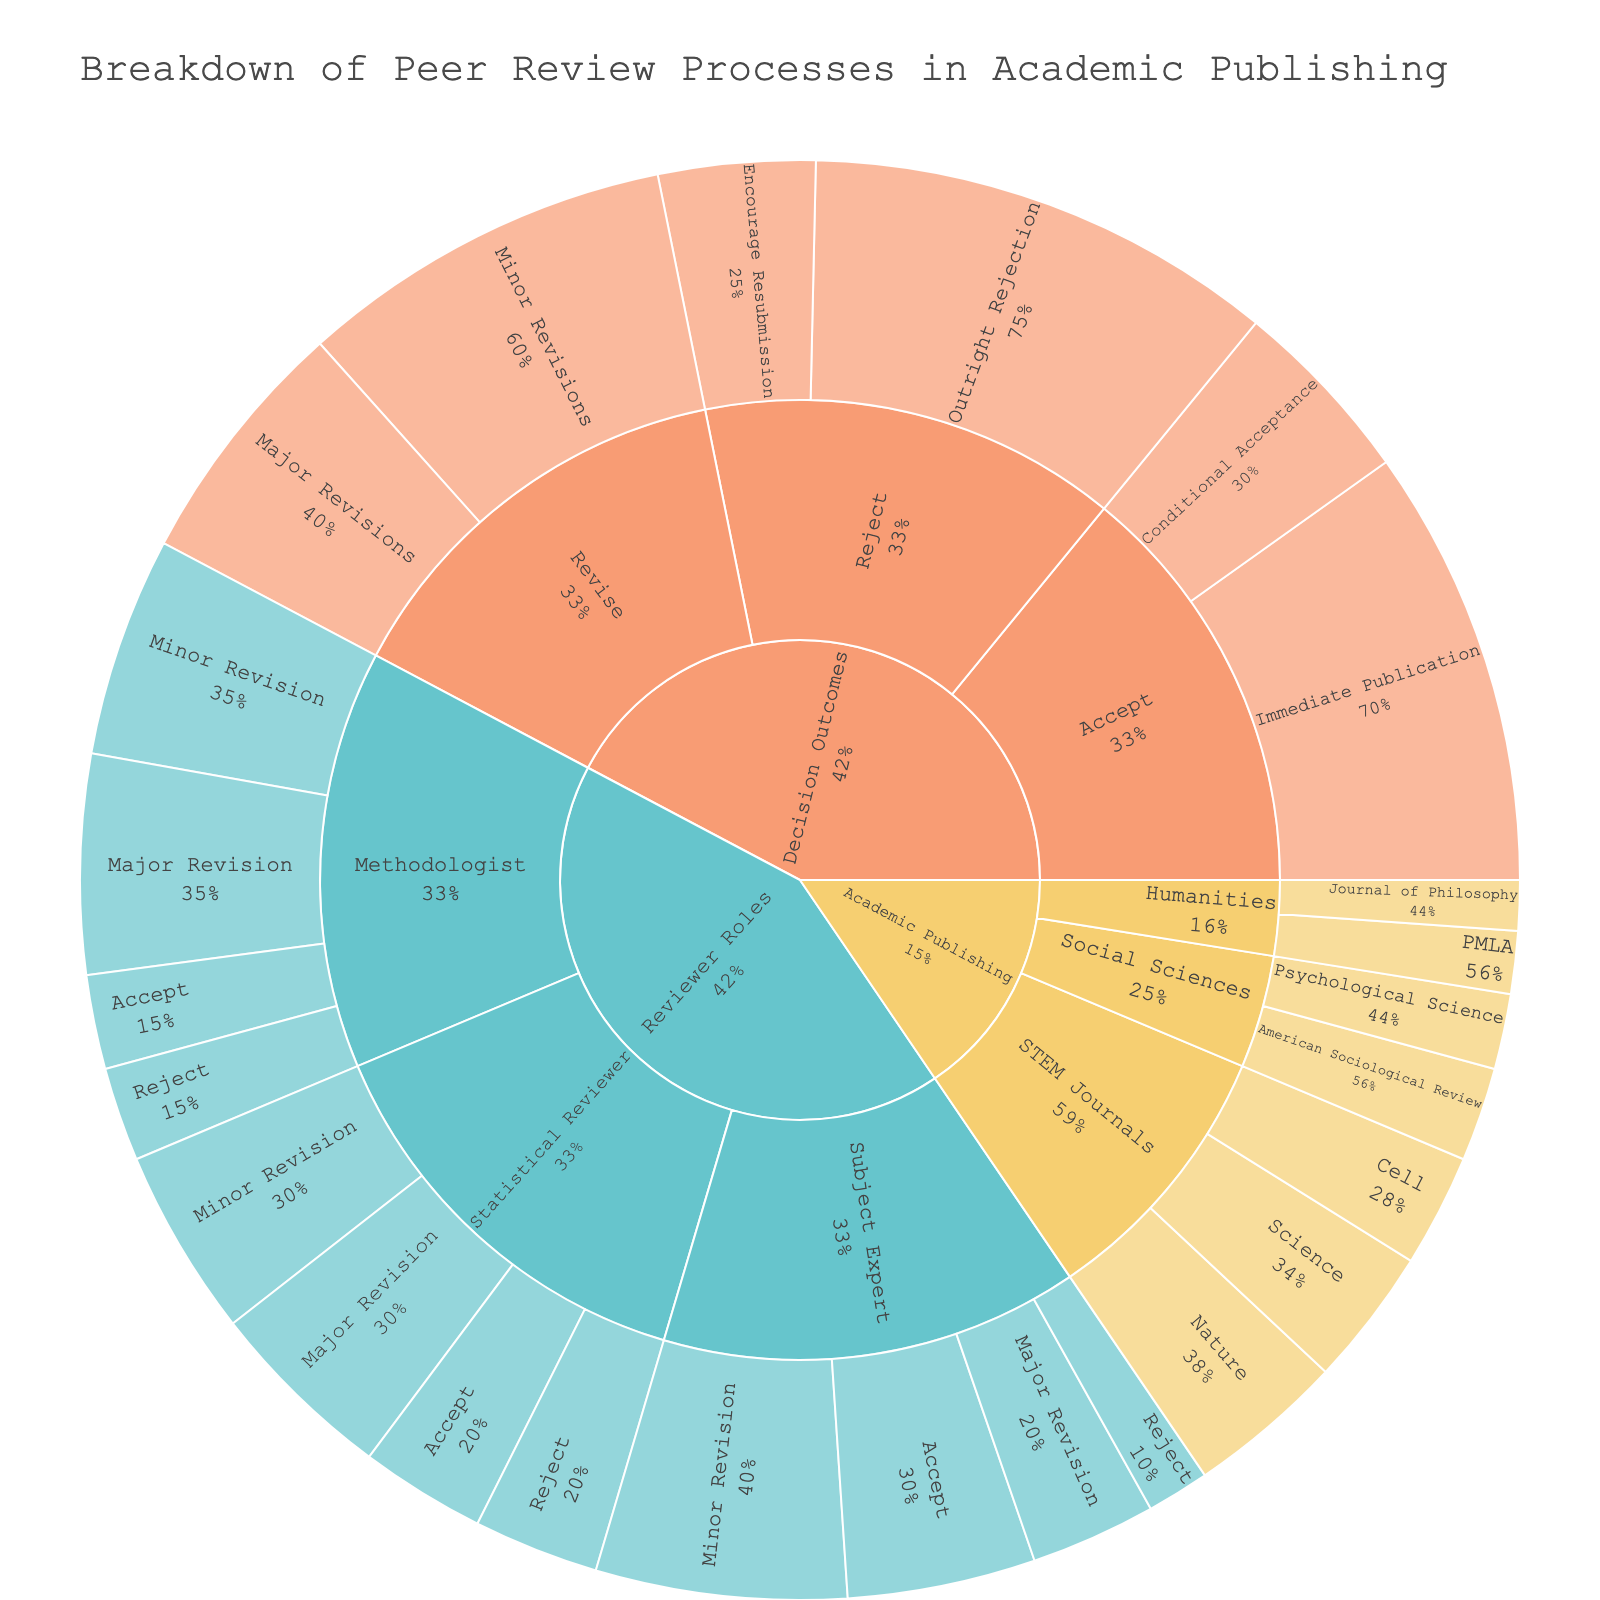What is the title of the Sunburst Plot? Look at the central area or the top part of the figure where titles are typically located.
Answer: Breakdown of Peer Review Processes in Academic Publishing How many subcategories are under the category "Academic Publishing"? Refer to the branches stemming from "Academic Publishing."
Answer: Three Which STEM Journal has the highest value and what is it? Identify the segment with the largest area under "STEM Journals."
Answer: Nature, 25 What is the total value of reviews done by Subject Experts? Sum the values for Accept, Minor Revision, Major Revision, and Reject under "Subject Expert."
Answer: 100 Compare the values of Reject decisions between Methodologist and Statistical Reviewer. Which one is higher? Find and compare reject values under both "Methodologist" and "Statistical Reviewer."
Answer: Statistical Reviewer, 20 What percentage of "Immediate Publication" under Accept decisions contributes to the total "Decision Outcomes"? Divide the value of Immediate Publication (70) by the sum of all Decision Outcome values (300) and convert to percentage.
Answer: 23.3% What is the combined value of "Minor Revisions" across all categories? Sum the values of Minor Revisions under Reviewer Roles and Decision Outcomes.
Answer: 130 Which "Humanities" journal has the lowest value and what is that value? Identify and compare the segments under "Humanities."
Answer: Journal of Philosophy, 8 What is the color scheme used to differentiate categories in the Sunburst Plot? Look at the segments' colors; the color differences represent different categories.
Answer: Pastel colors Is the value of "Conditional Acceptance" higher or lower than "Encourage Resubmission"? Compare the values of Conditional Acceptance (30) and Encourage Resubmission (25).
Answer: Higher 